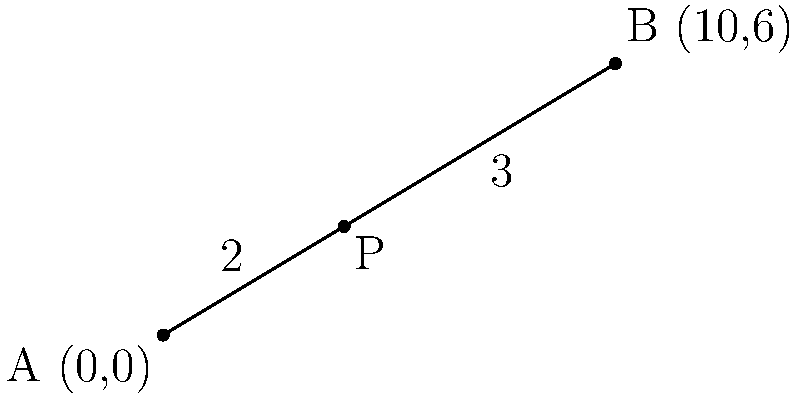In a novel, the character arc of the protagonist is represented by a line segment AB. Point A(0,0) represents the character's initial state, and point B(10,6) represents their final transformation. If point P divides AB in the ratio 2:3, symbolizing a crucial turning point in the character's development, find the coordinates of point P. To find the coordinates of point P, we can use the section formula:

1) The section formula states that if a point P divides a line segment AB in the ratio m:n, then the coordinates of P are given by:

   $P_x = \frac{mx_2 + nx_1}{m+n}$ and $P_y = \frac{my_2 + ny_1}{m+n}$

   Where $(x_1, y_1)$ are the coordinates of A and $(x_2, y_2)$ are the coordinates of B.

2) In this case, m:n = 2:3, A(0,0), and B(10,6)

3) For the x-coordinate:
   $P_x = \frac{2(10) + 3(0)}{2+3} = \frac{20}{5} = 4$

4) For the y-coordinate:
   $P_y = \frac{2(6) + 3(0)}{2+3} = \frac{12}{5} = 2.4$

5) Therefore, the coordinates of point P are (4, 2.4).
Answer: P(4, 2.4) 